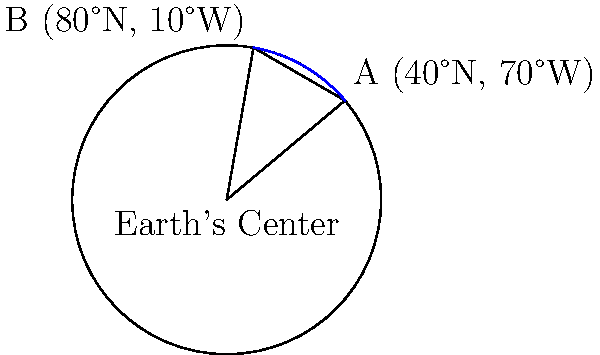Two cities, A and B, are located at (40°N, 70°W) and (80°N, 10°W) respectively on a map. Given that the Earth's radius is approximately 6,371 km, what is the shortest distance between these two cities along the Earth's surface? Round your answer to the nearest kilometer. To solve this problem, we'll use the Haversine formula, which is ideal for calculating great-circle distances on a sphere. Here's a step-by-step approach:

1. Convert latitude and longitude to radians:
   $\text{lat}_1 = 40° \times \frac{\pi}{180} = 0.6981$ radians
   $\text{lon}_1 = -70° \times \frac{\pi}{180} = -1.2217$ radians
   $\text{lat}_2 = 80° \times \frac{\pi}{180} = 1.3963$ radians
   $\text{lon}_2 = -10° \times \frac{\pi}{180} = -0.1745$ radians

2. Calculate the difference in longitude:
   $\Delta\text{lon} = \text{lon}_2 - \text{lon}_1 = 1.0472$ radians

3. Apply the Haversine formula:
   $a = \sin^2(\frac{\Delta\text{lat}}{2}) + \cos(\text{lat}_1) \times \cos(\text{lat}_2) \times \sin^2(\frac{\Delta\text{lon}}{2})$
   
   $a = \sin^2(\frac{1.3963 - 0.6981}{2}) + \cos(0.6981) \times \cos(1.3963) \times \sin^2(\frac{1.0472}{2})$
   
   $a = 0.1175 + 0.7660 \times 0.2419 \times 0.2457 = 0.1638$

4. Calculate the central angle:
   $c = 2 \times \arctan2(\sqrt{a}, \sqrt{1-a}) = 0.8372$ radians

5. Calculate the distance:
   $d = R \times c = 6371 \times 0.8372 = 5333.96$ km

6. Round to the nearest kilometer:
   $d \approx 5334$ km
Answer: 5334 km 